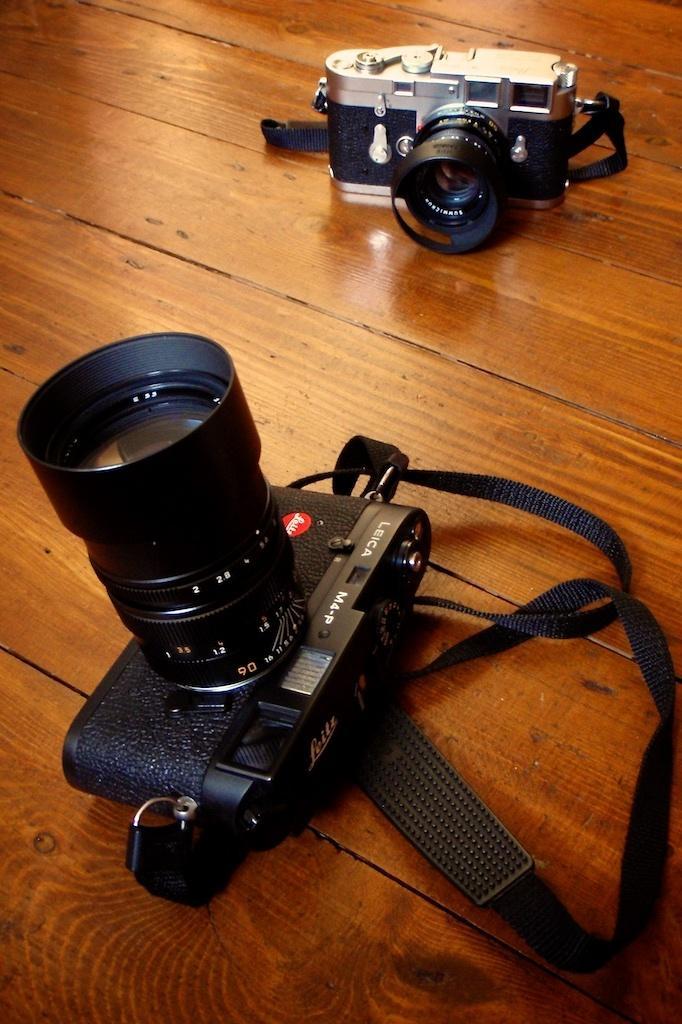Describe this image in one or two sentences. In this image, we can see two cameras kept on the brown color object. 